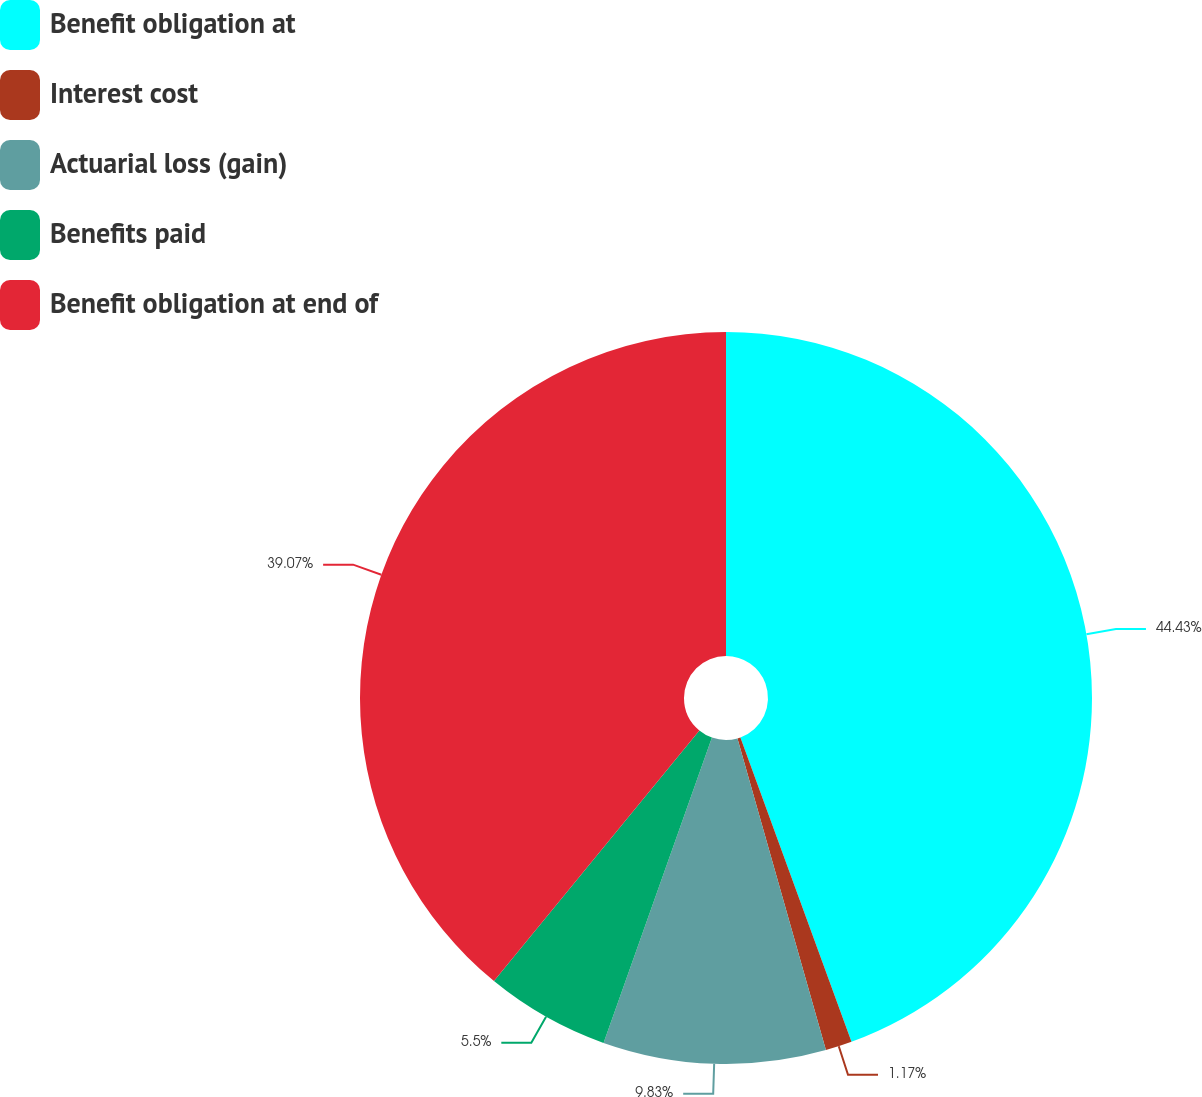Convert chart. <chart><loc_0><loc_0><loc_500><loc_500><pie_chart><fcel>Benefit obligation at<fcel>Interest cost<fcel>Actuarial loss (gain)<fcel>Benefits paid<fcel>Benefit obligation at end of<nl><fcel>44.43%<fcel>1.17%<fcel>9.83%<fcel>5.5%<fcel>39.07%<nl></chart> 